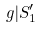<formula> <loc_0><loc_0><loc_500><loc_500>g | S _ { 1 } ^ { \prime }</formula> 